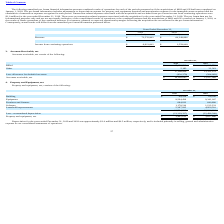According to Luna Innovations Incorporated's financial document, Was there any transaction-related expenses associated with the acquisition for the year ended December 31, 2018? There were no transaction-related expenses associated with the acquisition for the year ended December 31, 2018.. The document states: "$1.0 million for the year ended December 31, 2019. There were no transaction-related expenses associated with the acquisition for the year ended Decem..." Also, can you calculate: What is the change in Revenue from December 31, 2018 and 2019? Based on the calculation: 72,576,902-60,249,896, the result is 12327006. This is based on the information: "Revenue $ 72,576,902 $ 60,249,896 Revenue $ 72,576,902 $ 60,249,896..." The key data points involved are: 60,249,896, 72,576,902. Also, can you calculate: What is the average Revenue for December 31, 2018 and 2019? To answer this question, I need to perform calculations using the financial data. The calculation is: (72,576,902+60,249,896) / 2, which equals 66413399. This is based on the information: "Revenue $ 72,576,902 $ 60,249,896 Revenue $ 72,576,902 $ 60,249,896..." The key data points involved are: 60,249,896, 72,576,902. Additionally, In which year was Revenue less than 65,000,000? According to the financial document, 2018. The relevant text states: "2019 2018..." Also, What was the Income from continuing operations in 2019 and 2018 respectively? The document shows two values: $6,912,802 and $1,559,008. From the document: "Income from continuing operations $ 6,912,802 $ 1,559,008 Income from continuing operations $ 6,912,802 $ 1,559,008..." Also, What was the revenue in 2019? According to the financial document, $72,576,902. The relevant text states: "Revenue $ 72,576,902 $ 60,249,896..." 